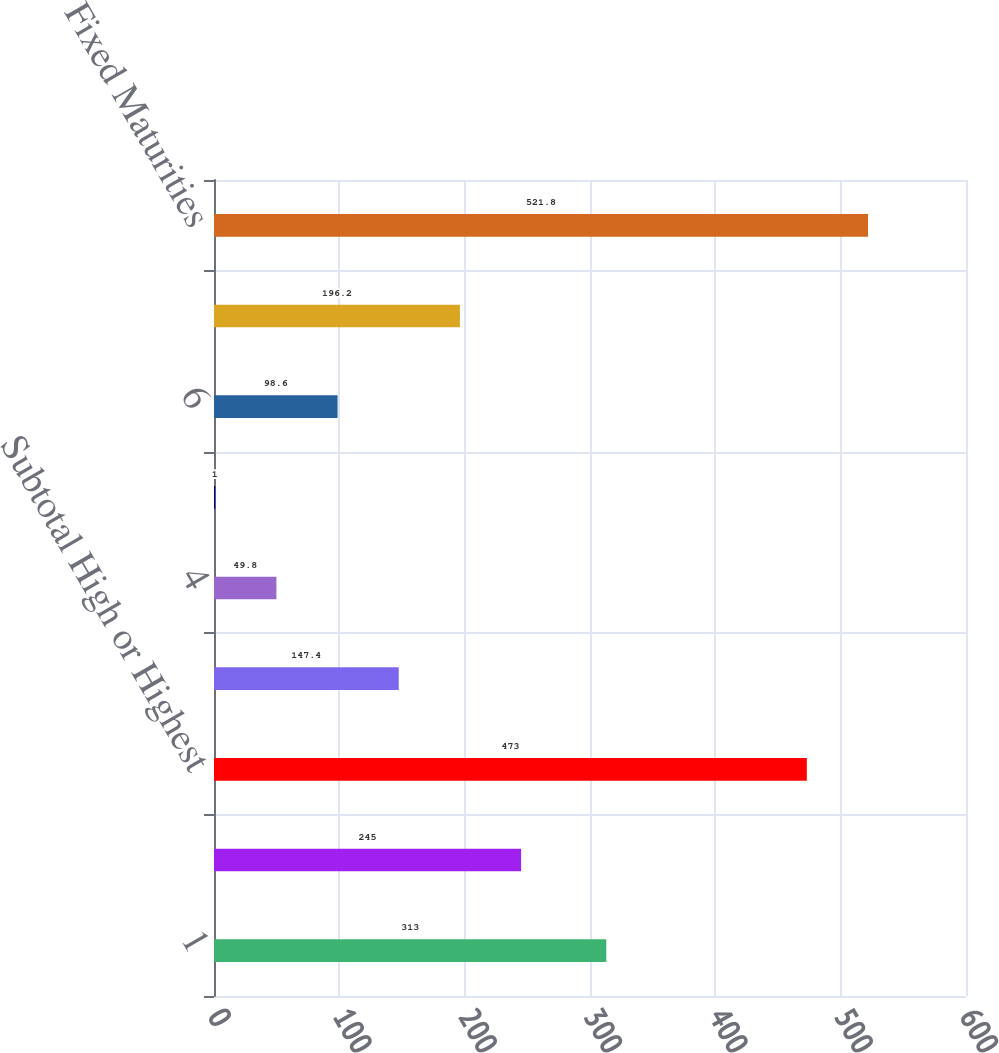Convert chart. <chart><loc_0><loc_0><loc_500><loc_500><bar_chart><fcel>1<fcel>2<fcel>Subtotal High or Highest<fcel>3<fcel>4<fcel>5<fcel>6<fcel>Subtotal Other Securities<fcel>Total Public Fixed Maturities<nl><fcel>313<fcel>245<fcel>473<fcel>147.4<fcel>49.8<fcel>1<fcel>98.6<fcel>196.2<fcel>521.8<nl></chart> 